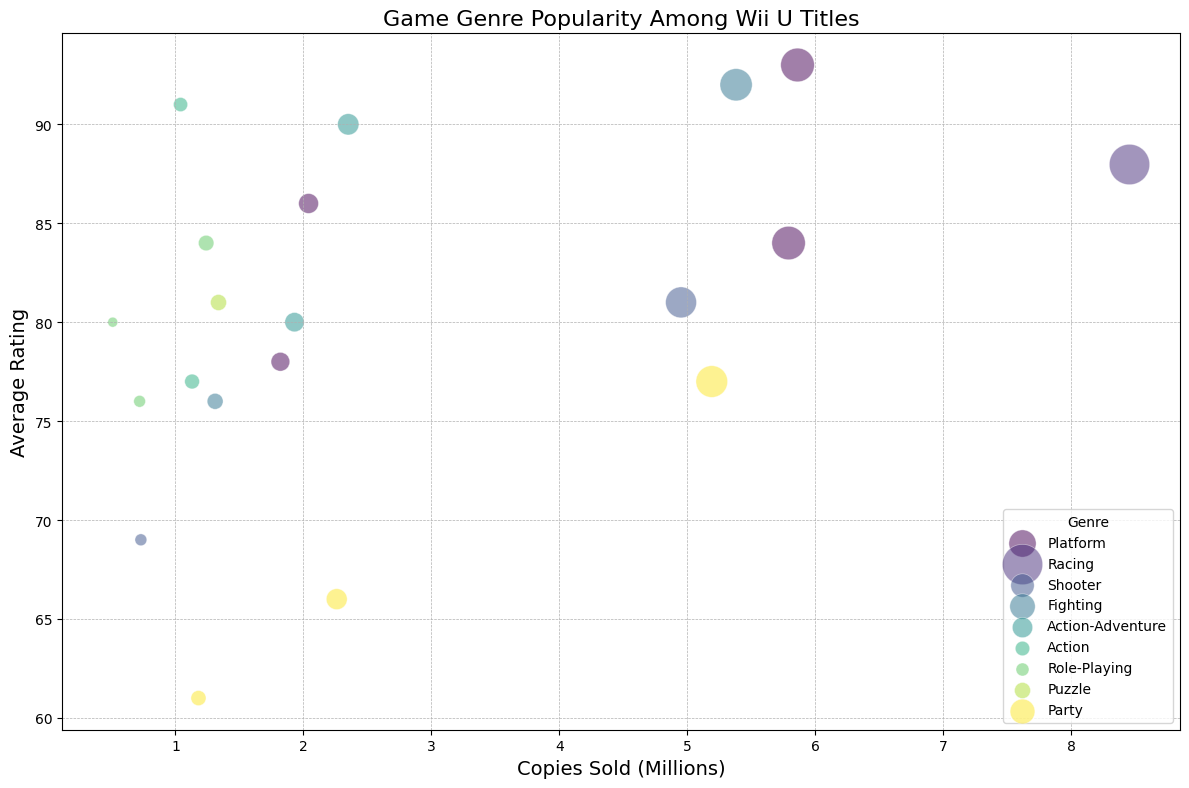Which genre has the highest average rating? From the figure, inspect the highest points on the y-axis. The genre that corresponds to these points is the one with the highest average rating.
Answer: Platform Which game has the largest bubble size in the Platform genre? Look for the largest bubble within the Platform genre by correlating bubble size with data points. The largest bubble represents the game with the highest copies sold within that genre.
Answer: Super Mario 3D World How do Party games compare to Fighting games in terms of average rating? Identify the average rating of Party and Fighting games by examining the y-axis values corresponding to these genres. Compare which one has generally higher ratings.
Answer: Fighting games generally have higher ratings What is the sum of average ratings for games in the Role-Playing genre? Identify all Role-Playing games and sum their average ratings from the y-axis labels in the figure.
Answer: 240 (84 + 80 + 76) Which genre's games tend to have sold fewer copies: Shooter or Puzzle? Compare the position of Shooter and Puzzle games on the x-axis. The genre with games positioned more towards the left indicates fewer copies sold.
Answer: Shooter Which game has the lowest average rating, and what genre does it belong to? Identify the lowest point on the y-axis and hover over or check the label to see which game and genre it corresponds to.
Answer: Game & Wario, Party What is the difference in copies sold between Super Smash Bros. for Wii U and New Super Mario Bros. U? Locate both games on the x-axis and subtract the smaller value from the larger one to find the difference in copies sold.
Answer: 0.41 million copies (5.79 - 5.38) What is the dominant genre in terms of the number of games shown in the figure? Count the number of bubbles representing each genre and determine which genre has the most games.
Answer: Action How do Puzzle games compare in average rating to Action-Adventure games? Check the average position on the y-axis for both Puzzle and Action-Adventure genres. Compare the general ratings to determine which is higher.
Answer: Action-Adventure games have higher ratings Which genres have games that are both highly rated and have sold many copies? Look for genres with bubbles that are positioned high on the y-axis (high rating) and far right on the x-axis (many copies sold).
Answer: Platform, Racing, Fighting 